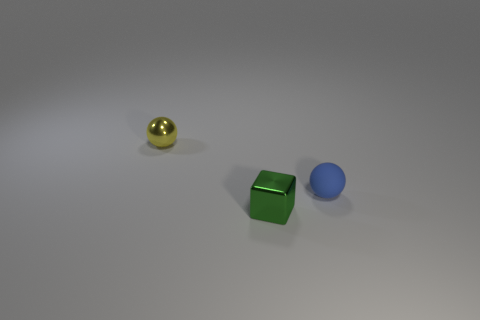Add 3 small yellow spheres. How many objects exist? 6 Subtract all blue balls. How many balls are left? 1 Subtract all balls. How many objects are left? 1 Subtract 1 cubes. How many cubes are left? 0 Subtract all yellow spheres. Subtract all brown cubes. How many spheres are left? 1 Subtract all red cubes. How many green balls are left? 0 Subtract all small gray objects. Subtract all small shiny blocks. How many objects are left? 2 Add 1 small shiny spheres. How many small shiny spheres are left? 2 Add 3 cyan blocks. How many cyan blocks exist? 3 Subtract 0 cyan blocks. How many objects are left? 3 